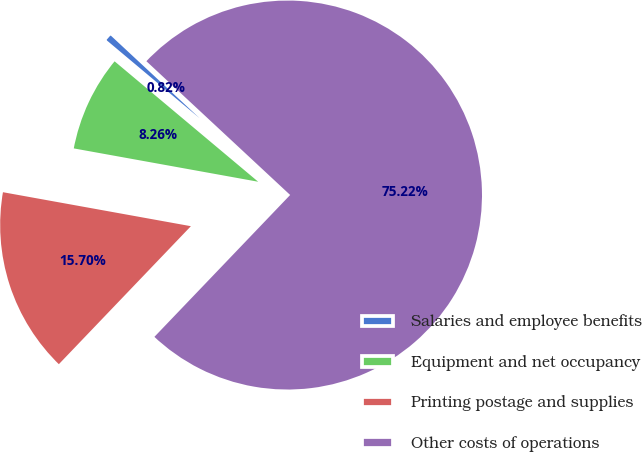<chart> <loc_0><loc_0><loc_500><loc_500><pie_chart><fcel>Salaries and employee benefits<fcel>Equipment and net occupancy<fcel>Printing postage and supplies<fcel>Other costs of operations<nl><fcel>0.82%<fcel>8.26%<fcel>15.7%<fcel>75.23%<nl></chart> 